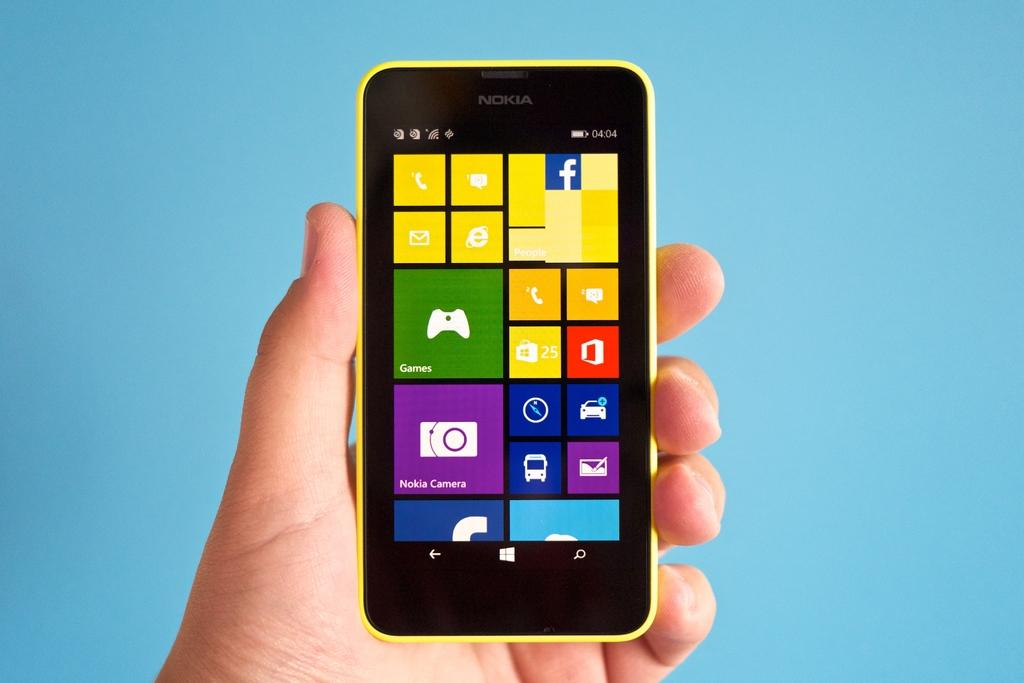<image>
Give a short and clear explanation of the subsequent image. a Nokia Camera that is on a phone 